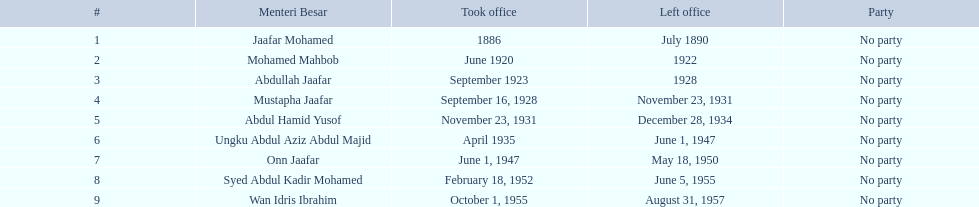Who were all the menteri besars? Jaafar Mohamed, Mohamed Mahbob, Abdullah Jaafar, Mustapha Jaafar, Abdul Hamid Yusof, Ungku Abdul Aziz Abdul Majid, Onn Jaafar, Syed Abdul Kadir Mohamed, Wan Idris Ibrahim. When did they begin their term? 1886, June 1920, September 1923, September 16, 1928, November 23, 1931, April 1935, June 1, 1947, February 18, 1952, October 1, 1955. And when did they exit? July 1890, 1922, 1928, November 23, 1931, December 28, 1934, June 1, 1947, May 18, 1950, June 5, 1955, August 31, 1957. Now, who served for under four years? Mohamed Mahbob. 